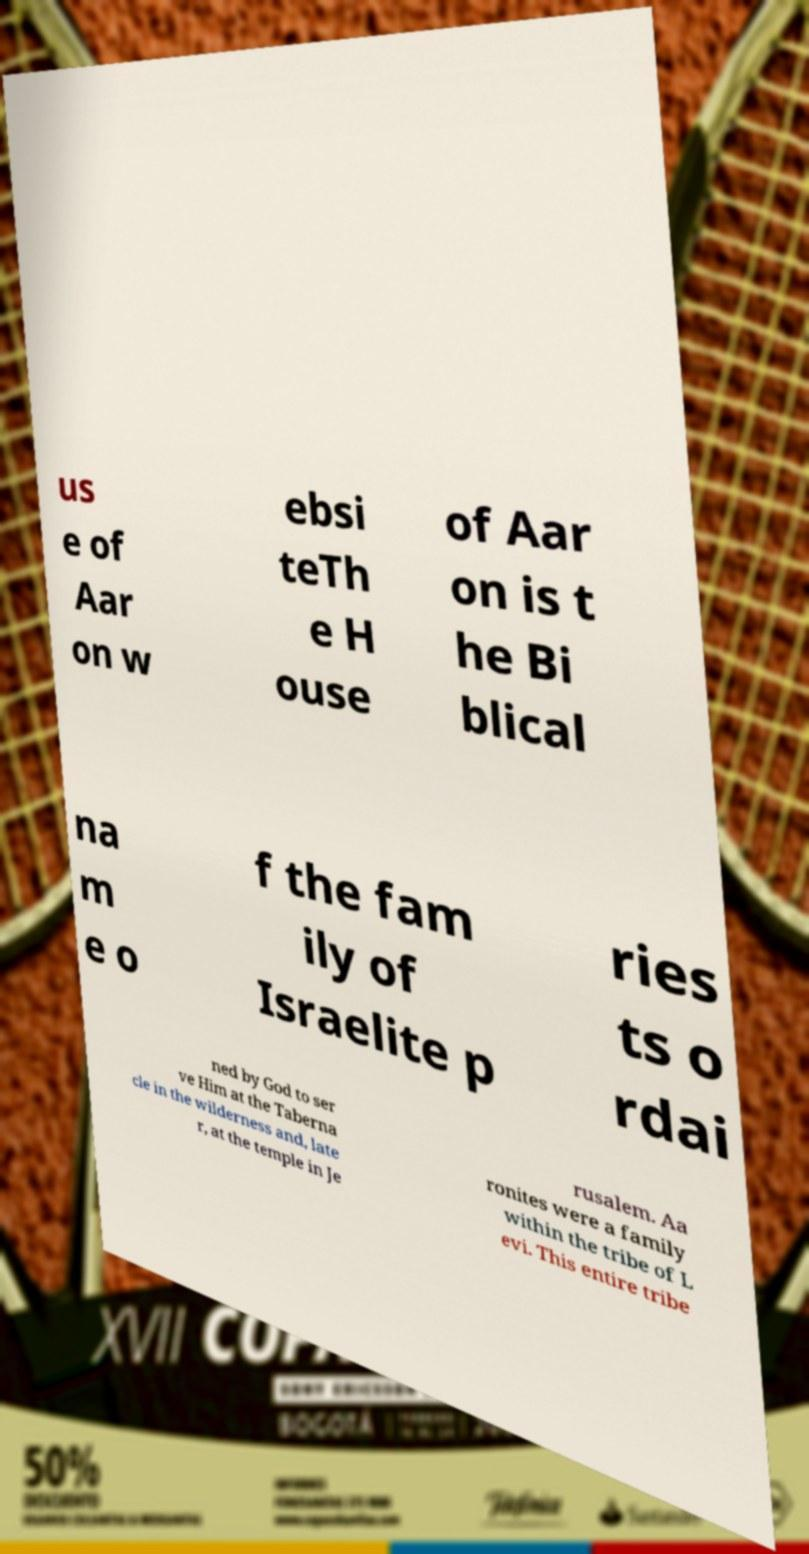Can you read and provide the text displayed in the image?This photo seems to have some interesting text. Can you extract and type it out for me? us e of Aar on w ebsi teTh e H ouse of Aar on is t he Bi blical na m e o f the fam ily of Israelite p ries ts o rdai ned by God to ser ve Him at the Taberna cle in the wilderness and, late r, at the temple in Je rusalem. Aa ronites were a family within the tribe of L evi. This entire tribe 